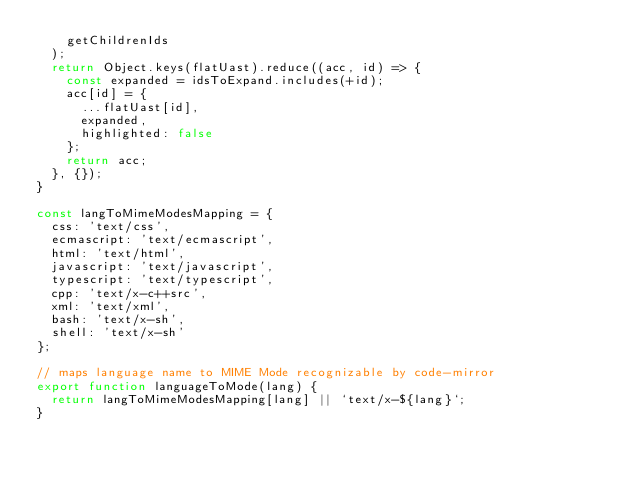Convert code to text. <code><loc_0><loc_0><loc_500><loc_500><_JavaScript_>    getChildrenIds
  );
  return Object.keys(flatUast).reduce((acc, id) => {
    const expanded = idsToExpand.includes(+id);
    acc[id] = {
      ...flatUast[id],
      expanded,
      highlighted: false
    };
    return acc;
  }, {});
}

const langToMimeModesMapping = {
  css: 'text/css',
  ecmascript: 'text/ecmascript',
  html: 'text/html',
  javascript: 'text/javascript',
  typescript: 'text/typescript',
  cpp: 'text/x-c++src',
  xml: 'text/xml',
  bash: 'text/x-sh',
  shell: 'text/x-sh'
};

// maps language name to MIME Mode recognizable by code-mirror
export function languageToMode(lang) {
  return langToMimeModesMapping[lang] || `text/x-${lang}`;
}
</code> 